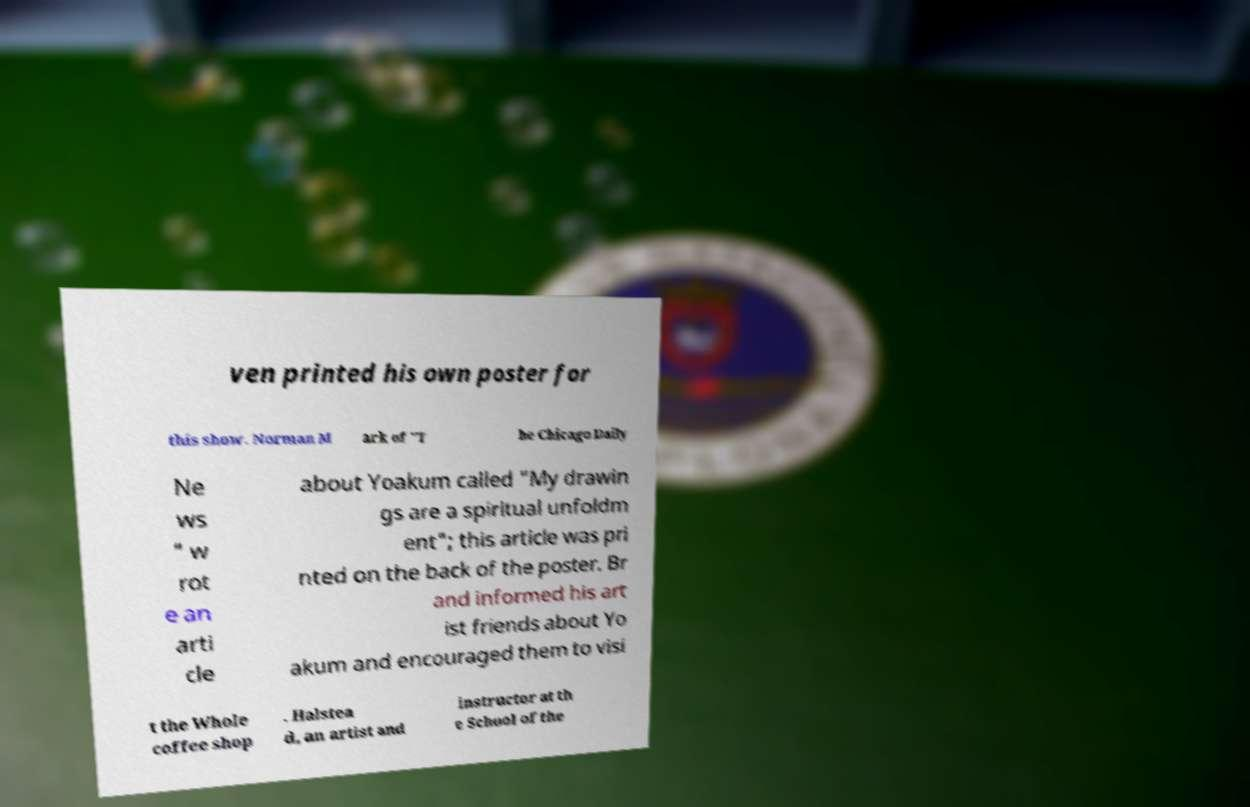For documentation purposes, I need the text within this image transcribed. Could you provide that? ven printed his own poster for this show. Norman M ark of "T he Chicago Daily Ne ws " w rot e an arti cle about Yoakum called "My drawin gs are a spiritual unfoldm ent"; this article was pri nted on the back of the poster. Br and informed his art ist friends about Yo akum and encouraged them to visi t the Whole coffee shop . Halstea d, an artist and instructor at th e School of the 